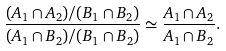<formula> <loc_0><loc_0><loc_500><loc_500>\frac { ( A _ { 1 } \cap A _ { 2 } ) / ( B _ { 1 } \cap B _ { 2 } ) } { ( A _ { 1 } \cap B _ { 2 } ) / ( B _ { 1 } \cap B _ { 2 } ) } \simeq \frac { A _ { 1 } \cap A _ { 2 } } { A _ { 1 } \cap B _ { 2 } } .</formula> 